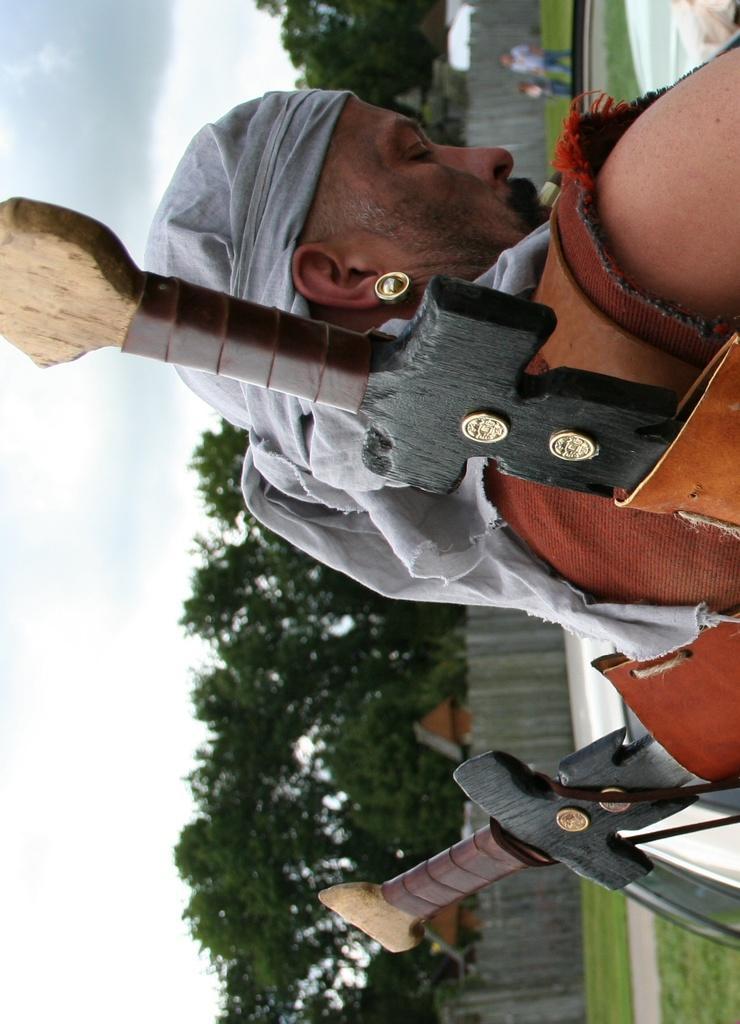How would you summarize this image in a sentence or two? In this picture we can see a man in the front, he is carrying two swords, at the right bottom there is grass, in the background we can see fencing and trees, there are two persons at the top of the picture, we can see the sky on the left side of the picture. 